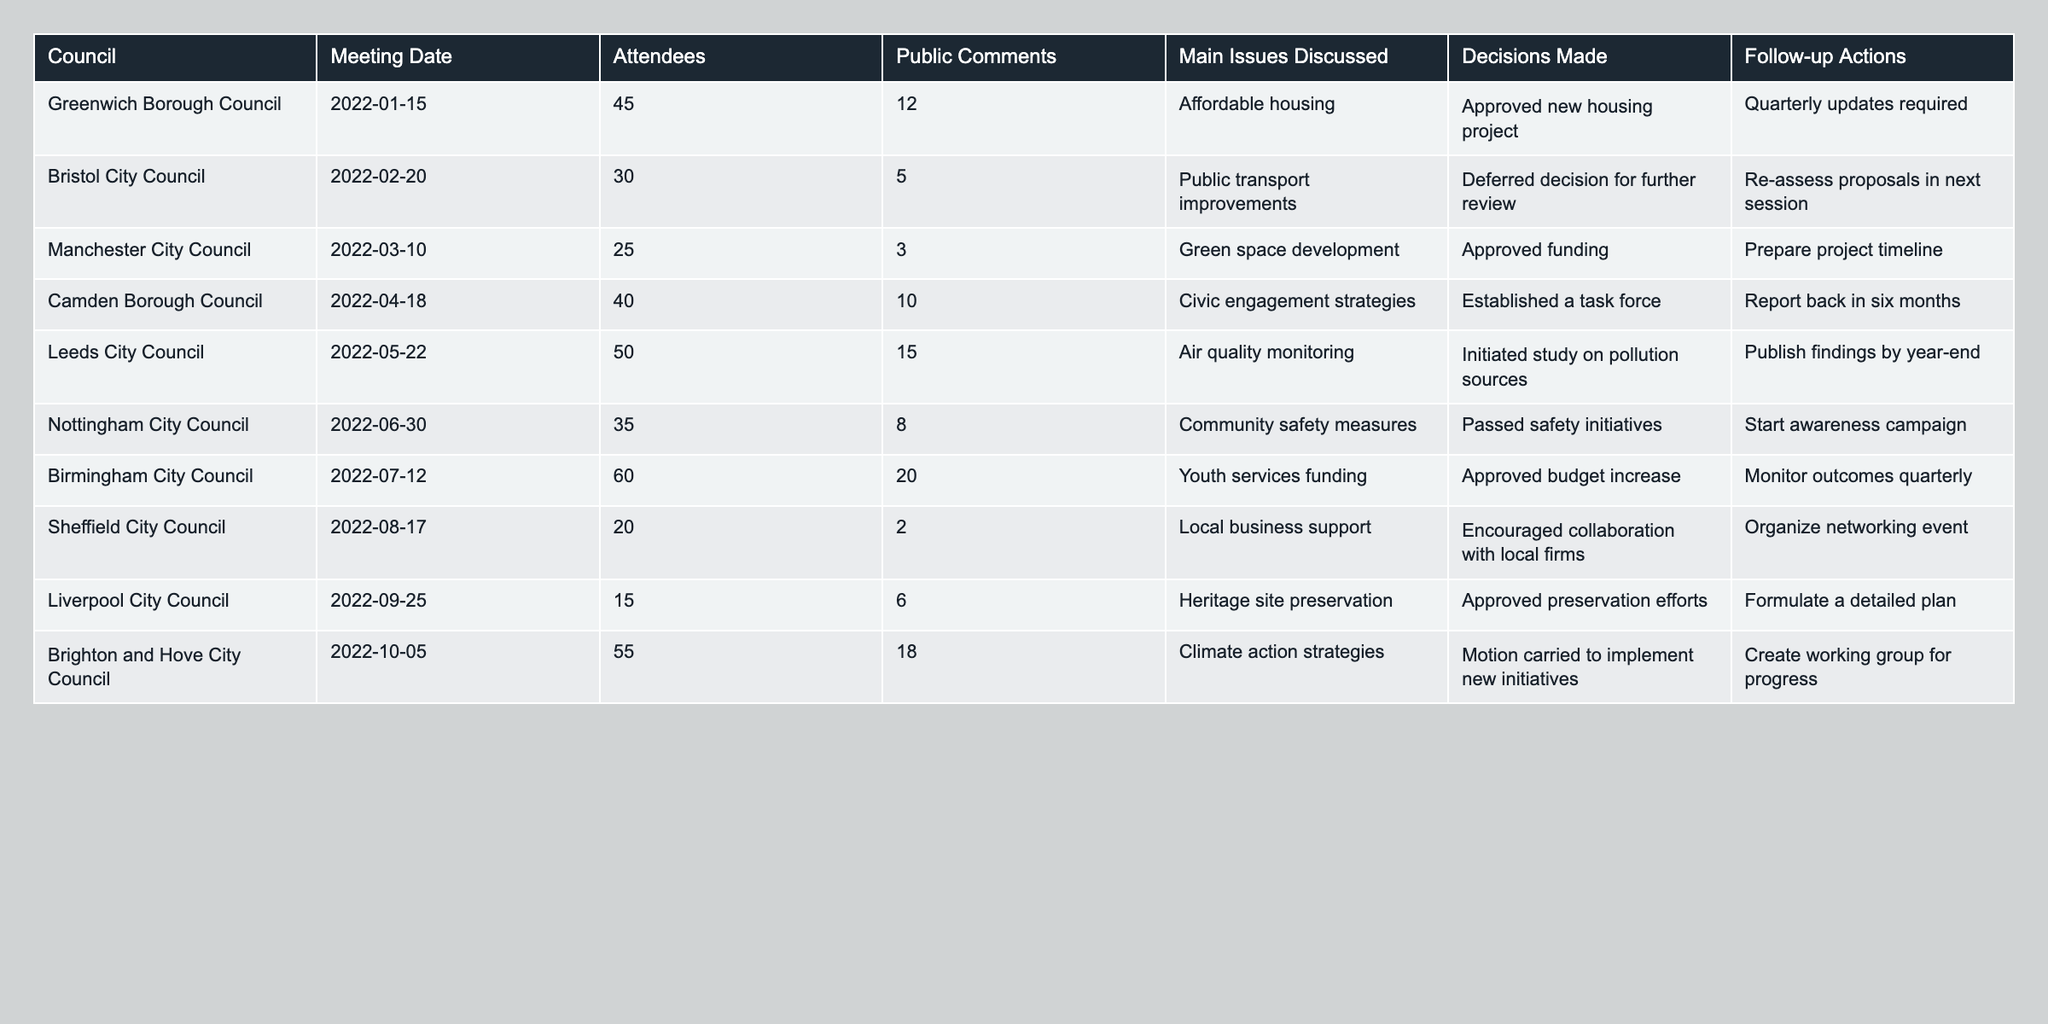What was the highest number of attendees at a council meeting? The highest number of attendees recorded in the table is 60, which occurred at Birmingham City Council on July 12, 2022.
Answer: 60 Which council had the least public comments and how many were there? Sheffield City Council had the least public comments, with a total of 2 comments during the meeting on August 17, 2022.
Answer: 2 How many councils approved decisions regarding funding? Five councils approved decisions specifically related to funding: Manchester, Birmingham, and Nottingham City Councils approved budget increases, and Bristol City Council deferred decisions for review, which implies additional consideration for funding.
Answer: 5 What is the average number of public comments across all councils? The total number of public comments is 76 (12 + 5 + 3 + 10 + 15 + 8 + 20 + 2 + 6 + 18). With 10 councils in total, we divide 76 by 10, resulting in an average of 7.6 public comments per council meeting.
Answer: 7.6 Did any councils address climate action strategies? Yes, Brighton and Hove City Council discussed climate action strategies during their meeting, where a motion was carried to implement new initiatives.
Answer: Yes Which council had the most issues discussed and what were they? Birmingham City Council had the most issues discussed, focusing on youth services funding during their meeting, which addressed various needs of the community.
Answer: Youth services funding What was the follow-up action required after the Nottingham City Council meeting? After the Nottingham City Council on June 30, 2022, the follow-up action required was to start an awareness campaign regarding the community safety measures that were passed.
Answer: Start awareness campaign How many councils established follow-up actions involving reports or timelines? Four councils established follow-up actions involving reports or timelines: Camden Borough Council (report back in six months), Leeds City Council (publish findings by year-end), Birmingham City Council (monitor outcomes quarterly), and Brighton and Hove City Council (create working group for progress).
Answer: 4 What percentage of total attendees provided public comments for Bristol City Council? Bristol City Council had 30 attendees and received 5 public comments. To find the percentage, we divide 5 by 30 and multiply by 100, yielding approximately 16.67%.
Answer: 16.67% Identify the council with the largest number of public comments and state the number. Birmingham City Council had the largest number of public comments at 20 during their meeting on July 12, 2022.
Answer: 20 How many councils discussed affordable housing as a main issue? Only one council, Greenwich Borough Council, discussed affordable housing as the main issue during their meeting on January 15, 2022.
Answer: 1 